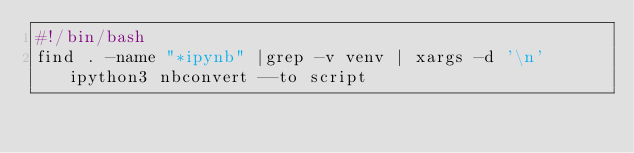<code> <loc_0><loc_0><loc_500><loc_500><_Bash_>#!/bin/bash
find . -name "*ipynb" |grep -v venv | xargs -d '\n' ipython3 nbconvert --to script
</code> 